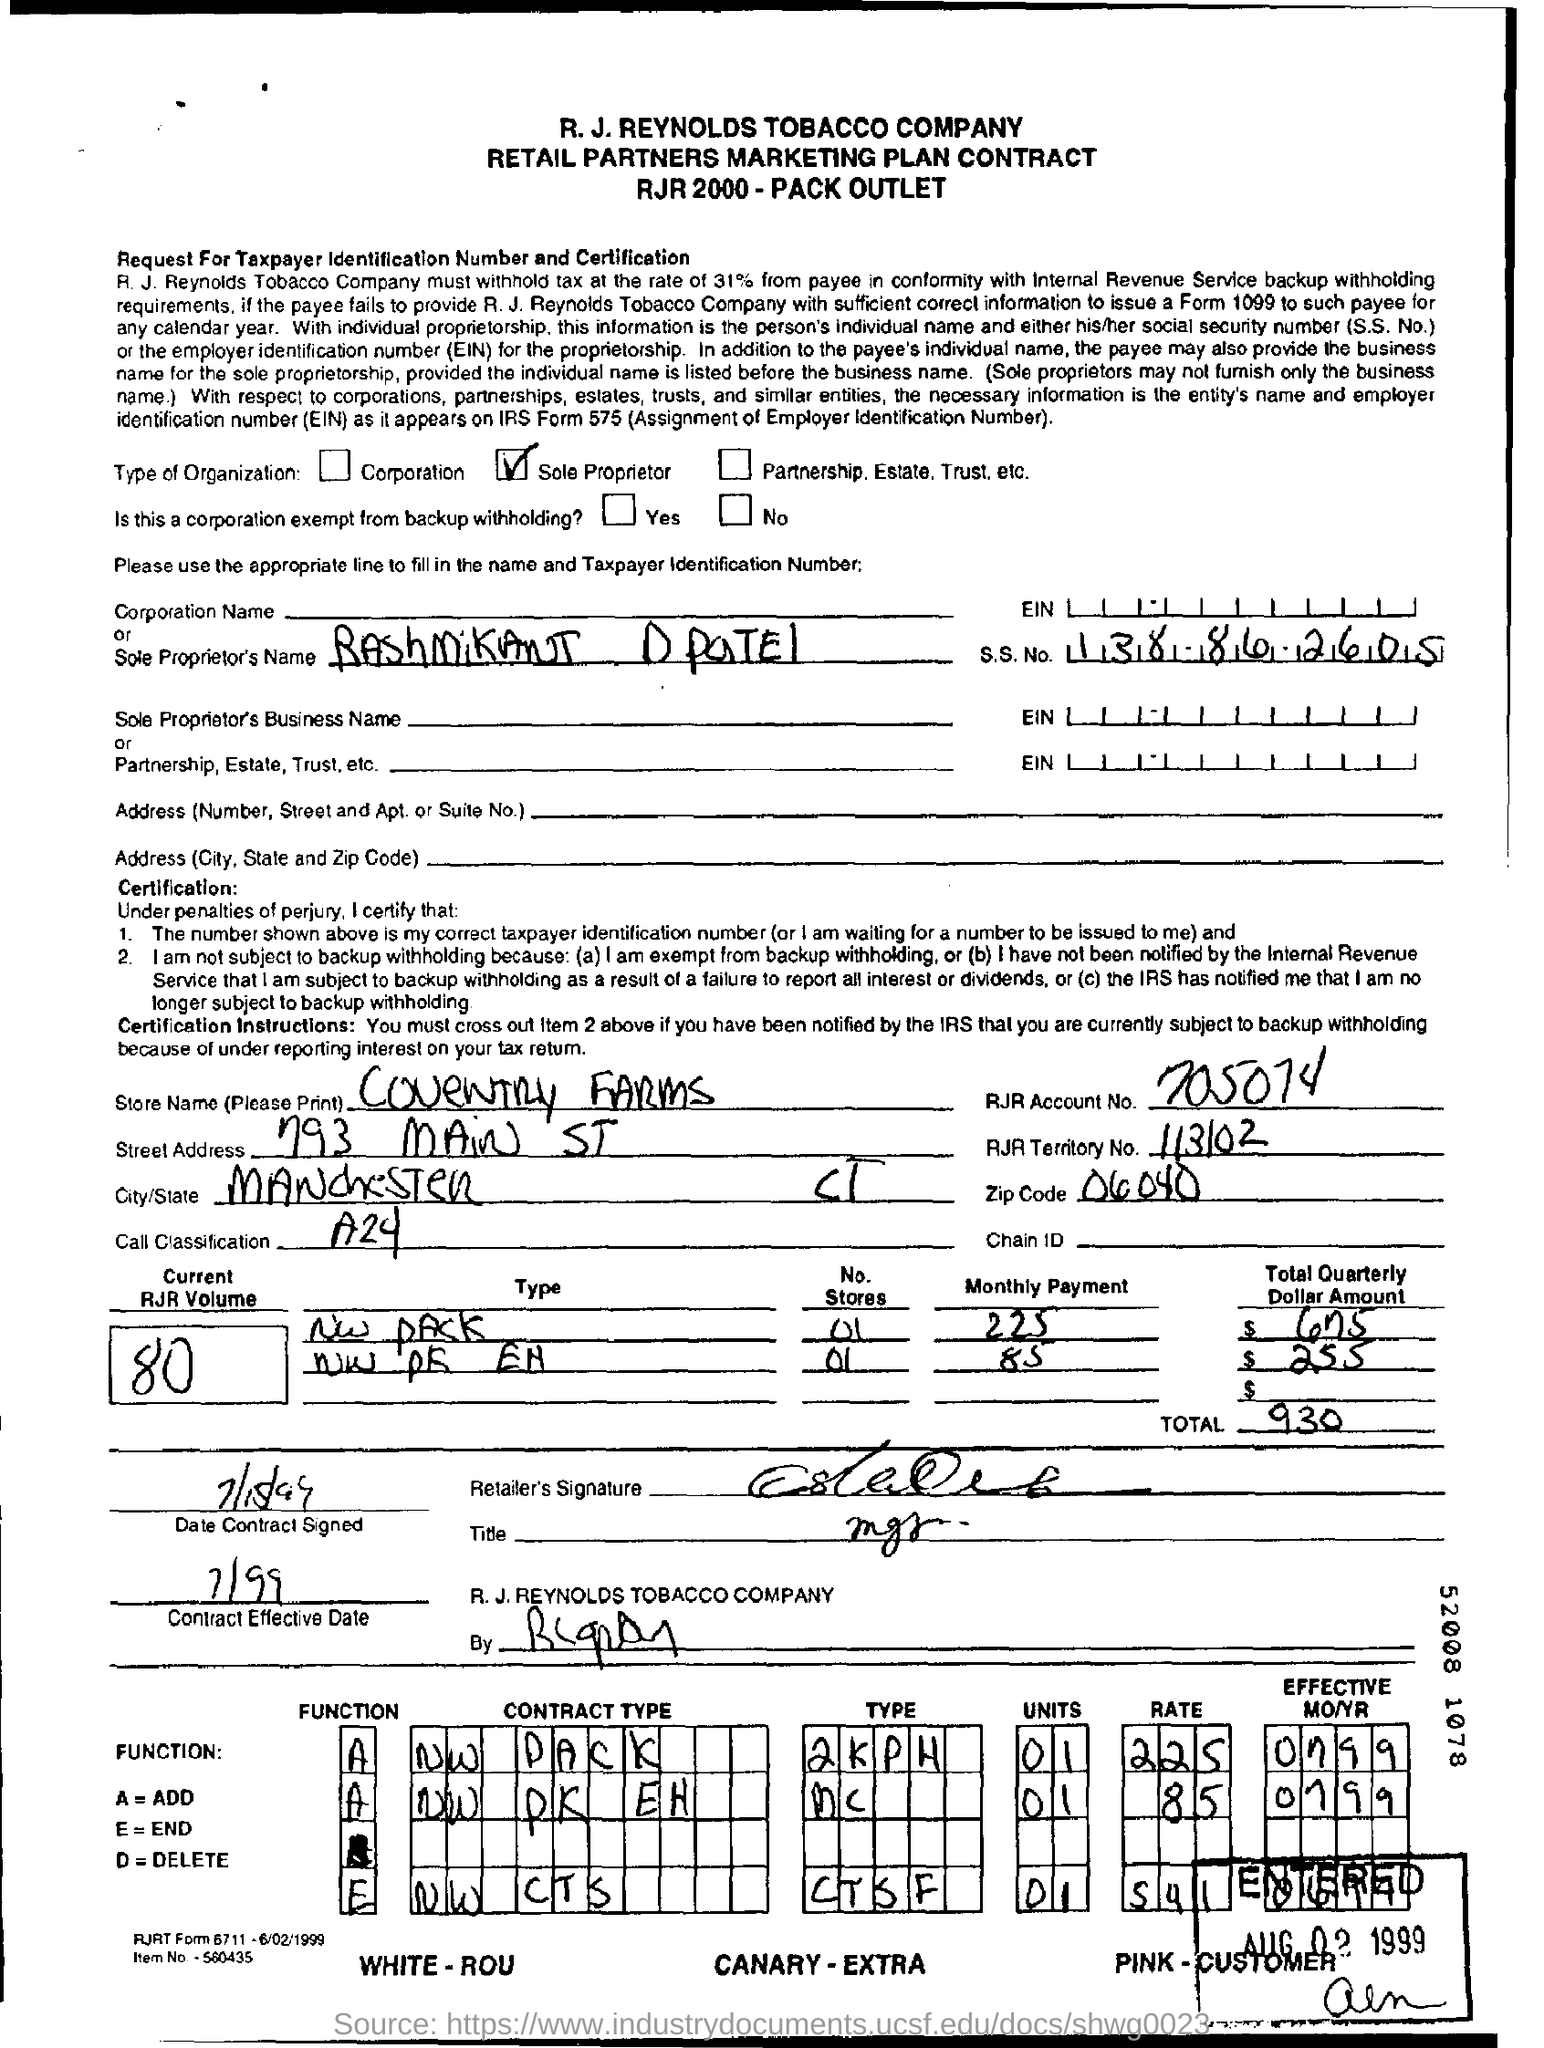What is the s.s. no. ?
Your answer should be very brief. 138-86-2605. What is the current rjr volume no.?
Keep it short and to the point. 80. How much is the total ?
Keep it short and to the point. 930. What is a= ?
Your answer should be very brief. Add. What is rjr account no.?
Keep it short and to the point. 705074. What is the street address of coventry farms ?
Offer a very short reply. 793 main st. 